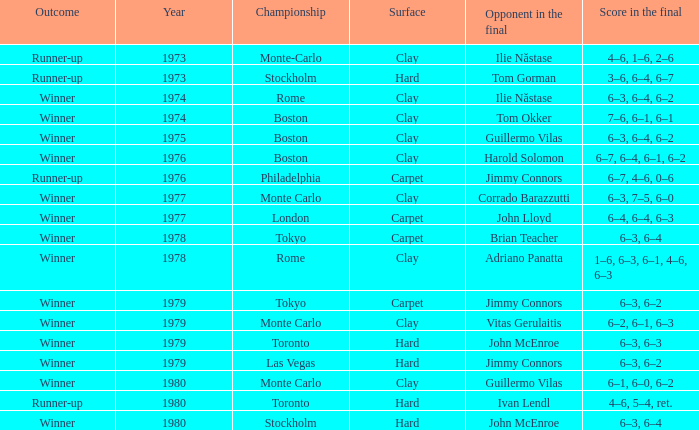I'm looking to parse the entire table for insights. Could you assist me with that? {'header': ['Outcome', 'Year', 'Championship', 'Surface', 'Opponent in the final', 'Score in the final'], 'rows': [['Runner-up', '1973', 'Monte-Carlo', 'Clay', 'Ilie Năstase', '4–6, 1–6, 2–6'], ['Runner-up', '1973', 'Stockholm', 'Hard', 'Tom Gorman', '3–6, 6–4, 6–7'], ['Winner', '1974', 'Rome', 'Clay', 'Ilie Năstase', '6–3, 6–4, 6–2'], ['Winner', '1974', 'Boston', 'Clay', 'Tom Okker', '7–6, 6–1, 6–1'], ['Winner', '1975', 'Boston', 'Clay', 'Guillermo Vilas', '6–3, 6–4, 6–2'], ['Winner', '1976', 'Boston', 'Clay', 'Harold Solomon', '6–7, 6–4, 6–1, 6–2'], ['Runner-up', '1976', 'Philadelphia', 'Carpet', 'Jimmy Connors', '6–7, 4–6, 0–6'], ['Winner', '1977', 'Monte Carlo', 'Clay', 'Corrado Barazzutti', '6–3, 7–5, 6–0'], ['Winner', '1977', 'London', 'Carpet', 'John Lloyd', '6–4, 6–4, 6–3'], ['Winner', '1978', 'Tokyo', 'Carpet', 'Brian Teacher', '6–3, 6–4'], ['Winner', '1978', 'Rome', 'Clay', 'Adriano Panatta', '1–6, 6–3, 6–1, 4–6, 6–3'], ['Winner', '1979', 'Tokyo', 'Carpet', 'Jimmy Connors', '6–3, 6–2'], ['Winner', '1979', 'Monte Carlo', 'Clay', 'Vitas Gerulaitis', '6–2, 6–1, 6–3'], ['Winner', '1979', 'Toronto', 'Hard', 'John McEnroe', '6–3, 6–3'], ['Winner', '1979', 'Las Vegas', 'Hard', 'Jimmy Connors', '6–3, 6–2'], ['Winner', '1980', 'Monte Carlo', 'Clay', 'Guillermo Vilas', '6–1, 6–0, 6–2'], ['Runner-up', '1980', 'Toronto', 'Hard', 'Ivan Lendl', '4–6, 5–4, ret.'], ['Winner', '1980', 'Stockholm', 'Hard', 'John McEnroe', '6–3, 6–4']]} Name the number of year for 6–3, 6–2 hard surface 1.0. 